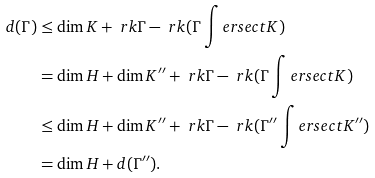Convert formula to latex. <formula><loc_0><loc_0><loc_500><loc_500>d ( \Gamma ) & \leq \dim K + \ r k \Gamma - \ r k ( \Gamma \int e r s e c t K ) \\ & = \dim H + \dim K ^ { \prime \prime } + \ r k \Gamma - \ r k ( \Gamma \int e r s e c t K ) \\ & \leq \dim H + \dim K ^ { \prime \prime } + \ r k \Gamma - \ r k ( \Gamma ^ { \prime \prime } \int e r s e c t K ^ { \prime \prime } ) \\ & = \dim H + d ( \Gamma ^ { \prime \prime } ) .</formula> 